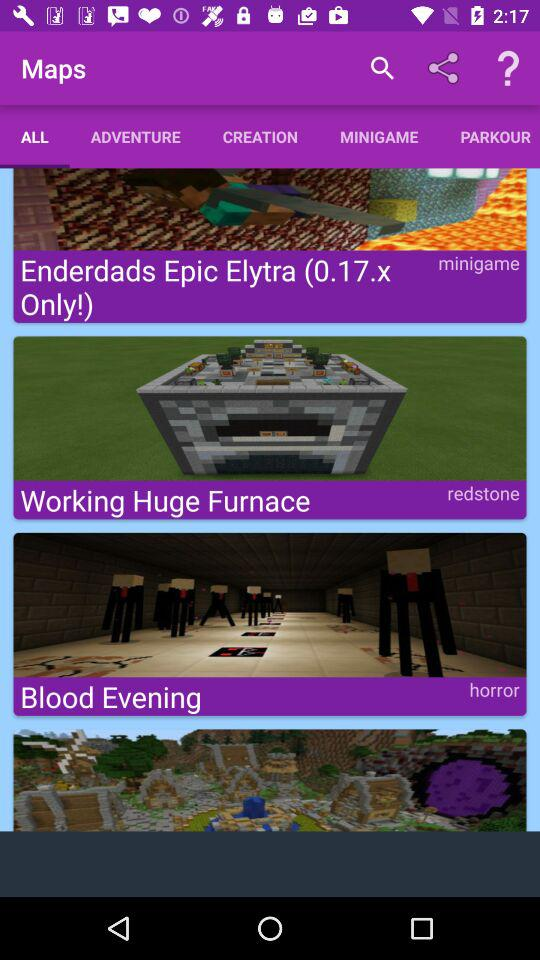How many of the items are in the minigame category?
Answer the question using a single word or phrase. 1 